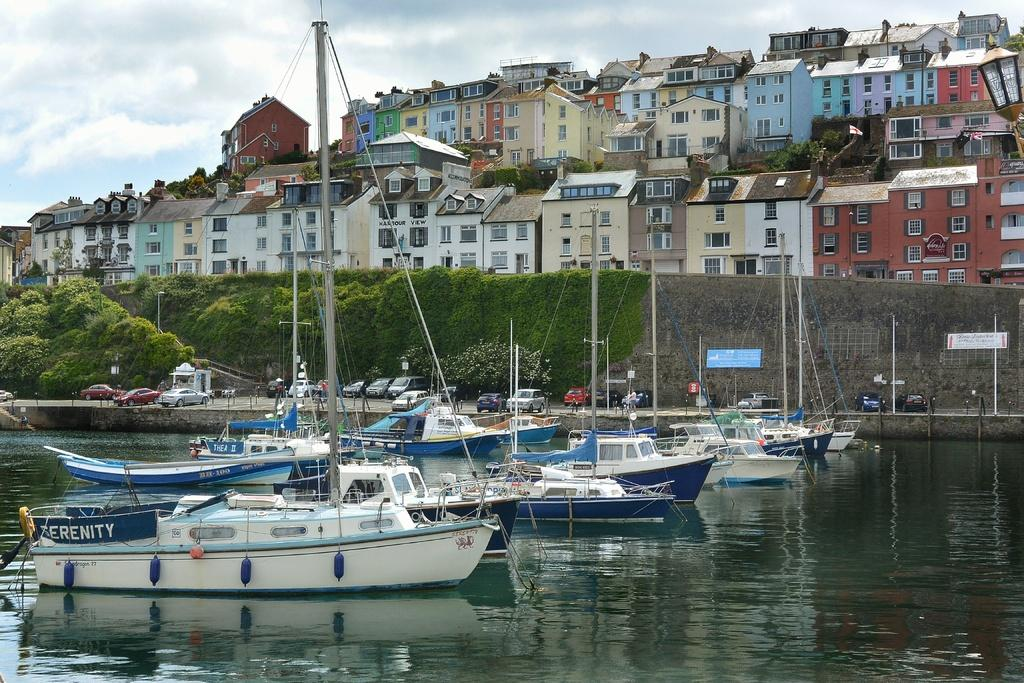What is on the water in the image? There are boats on the water in the image. What is on the road in the image? There are vehicles on the road in the image. What is on the wall in the image? There are boards on the wall in the image. What type of vegetation is present in the image? There are trees in the image. What are the tall, thin structures in the image? There are poles in the image. What type of structures are present in the image? There are buildings in the image. What can be seen in the background of the image? The sky with clouds is visible in the background of the image. How many geese are flying over the buildings in the image? There are no geese present in the image. Can you provide an example of a boat in the image? There is no need to provide an example, as the fact states that there are boats on the water in the image. Where was the image taken, considering the birth of the photographer? The birth of the photographer is not mentioned in the facts, so it cannot be used to determine the location of the image. 